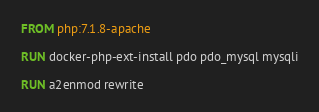Convert code to text. <code><loc_0><loc_0><loc_500><loc_500><_Dockerfile_>FROM php:7.1.8-apache

RUN docker-php-ext-install pdo pdo_mysql mysqli

RUN a2enmod rewrite
</code> 